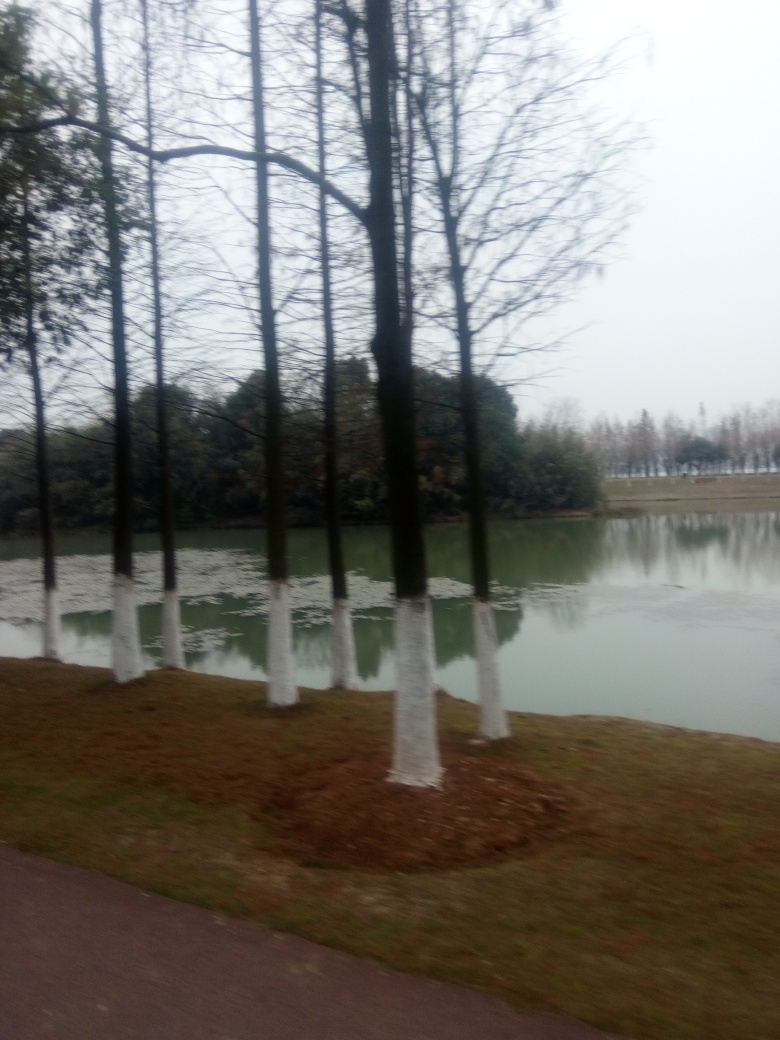What activities might take place in this location? Given the setting, with trees lined near a water body, it could be a park or recreational area. Activities might include walking, jogging, picnicking, or simply enjoying the scenery. The presence of a path also suggests it could be a popular spot for people to stroll and enjoy the outdoors. 